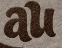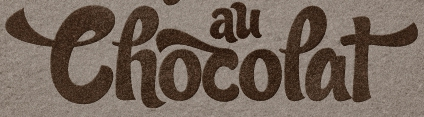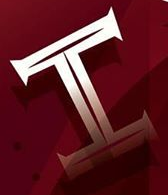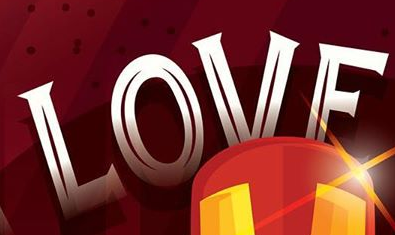Read the text from these images in sequence, separated by a semicolon. au; Thocopat; I; LOVE 